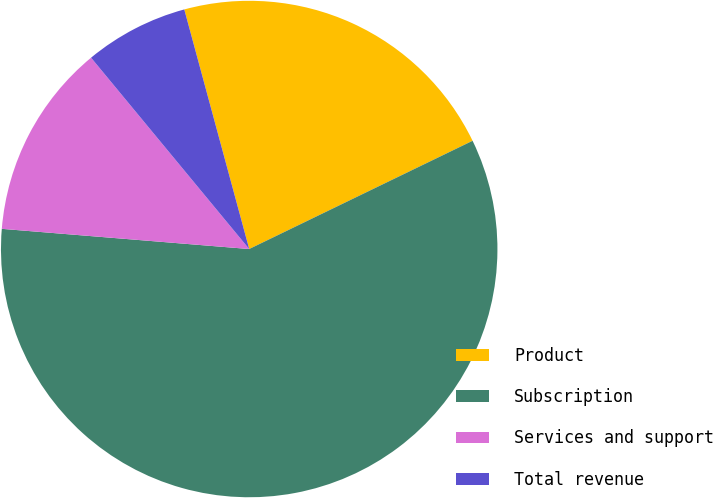Convert chart. <chart><loc_0><loc_0><loc_500><loc_500><pie_chart><fcel>Product<fcel>Subscription<fcel>Services and support<fcel>Total revenue<nl><fcel>22.03%<fcel>58.47%<fcel>12.71%<fcel>6.78%<nl></chart> 